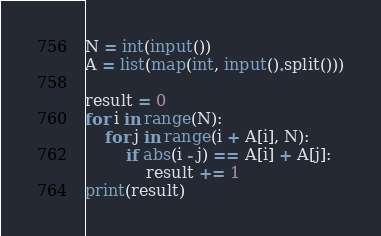Convert code to text. <code><loc_0><loc_0><loc_500><loc_500><_Python_>N = int(input())
A = list(map(int, input().split()))

result = 0
for i in range(N):
    for j in range(i + A[i], N):
        if abs(i - j) == A[i] + A[j]:
            result += 1
print(result)
</code> 